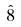Convert formula to latex. <formula><loc_0><loc_0><loc_500><loc_500>\hat { 8 }</formula> 